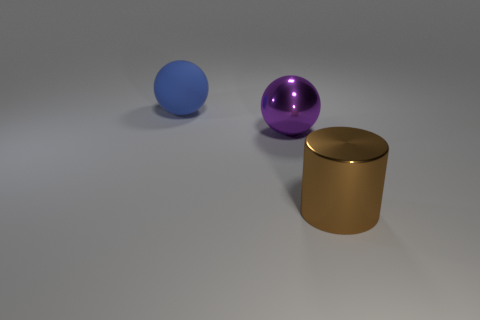Add 3 small red things. How many objects exist? 6 Subtract all blue balls. How many balls are left? 1 Subtract 1 balls. How many balls are left? 1 Subtract all cyan spheres. How many cyan cylinders are left? 0 Subtract all gray balls. Subtract all blue blocks. How many balls are left? 2 Subtract all shiny objects. Subtract all metal cylinders. How many objects are left? 0 Add 1 cylinders. How many cylinders are left? 2 Add 1 brown metallic cylinders. How many brown metallic cylinders exist? 2 Subtract 0 cyan spheres. How many objects are left? 3 Subtract all spheres. How many objects are left? 1 